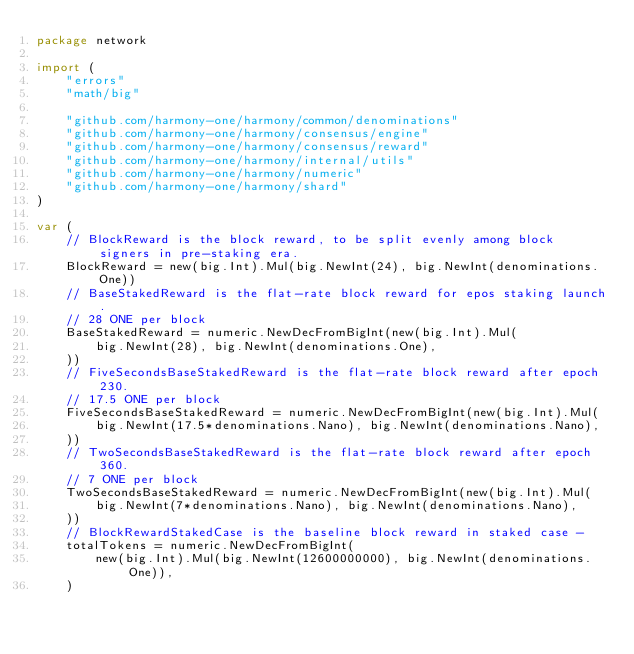<code> <loc_0><loc_0><loc_500><loc_500><_Go_>package network

import (
	"errors"
	"math/big"

	"github.com/harmony-one/harmony/common/denominations"
	"github.com/harmony-one/harmony/consensus/engine"
	"github.com/harmony-one/harmony/consensus/reward"
	"github.com/harmony-one/harmony/internal/utils"
	"github.com/harmony-one/harmony/numeric"
	"github.com/harmony-one/harmony/shard"
)

var (
	// BlockReward is the block reward, to be split evenly among block signers in pre-staking era.
	BlockReward = new(big.Int).Mul(big.NewInt(24), big.NewInt(denominations.One))
	// BaseStakedReward is the flat-rate block reward for epos staking launch.
	// 28 ONE per block
	BaseStakedReward = numeric.NewDecFromBigInt(new(big.Int).Mul(
		big.NewInt(28), big.NewInt(denominations.One),
	))
	// FiveSecondsBaseStakedReward is the flat-rate block reward after epoch 230.
	// 17.5 ONE per block
	FiveSecondsBaseStakedReward = numeric.NewDecFromBigInt(new(big.Int).Mul(
		big.NewInt(17.5*denominations.Nano), big.NewInt(denominations.Nano),
	))
	// TwoSecondsBaseStakedReward is the flat-rate block reward after epoch 360.
	// 7 ONE per block
	TwoSecondsBaseStakedReward = numeric.NewDecFromBigInt(new(big.Int).Mul(
		big.NewInt(7*denominations.Nano), big.NewInt(denominations.Nano),
	))
	// BlockRewardStakedCase is the baseline block reward in staked case -
	totalTokens = numeric.NewDecFromBigInt(
		new(big.Int).Mul(big.NewInt(12600000000), big.NewInt(denominations.One)),
	)</code> 